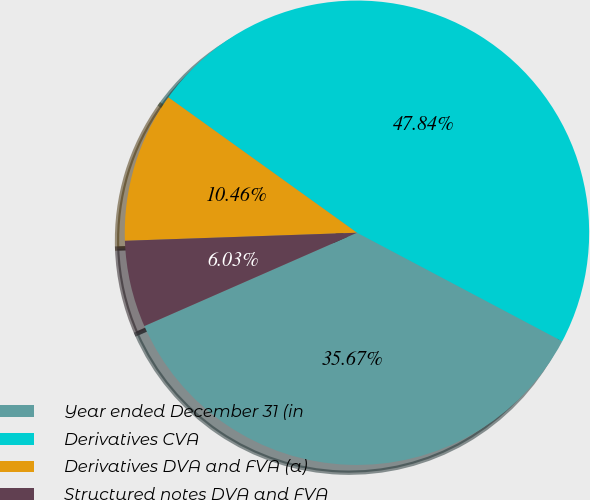Convert chart to OTSL. <chart><loc_0><loc_0><loc_500><loc_500><pie_chart><fcel>Year ended December 31 (in<fcel>Derivatives CVA<fcel>Derivatives DVA and FVA (a)<fcel>Structured notes DVA and FVA<nl><fcel>35.67%<fcel>47.84%<fcel>10.46%<fcel>6.03%<nl></chart> 